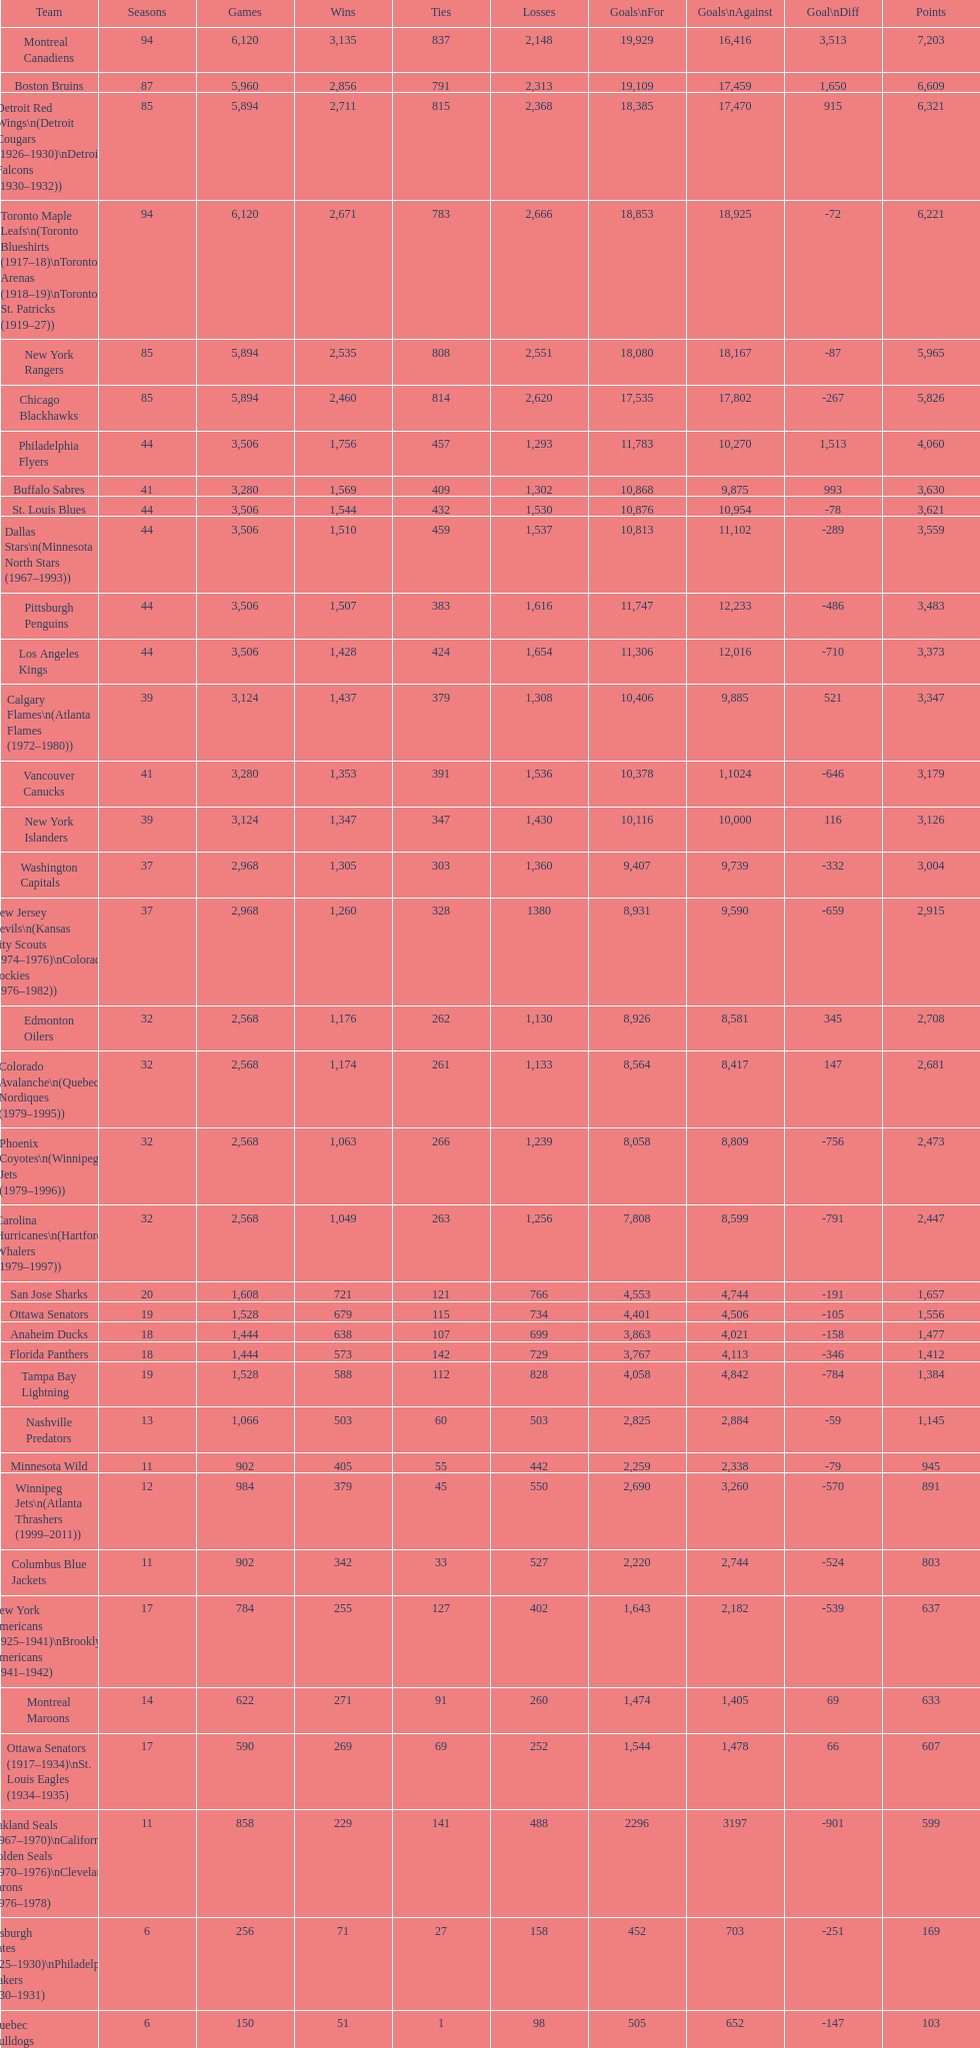Who holds the highest position on the list? Montreal Canadiens. 